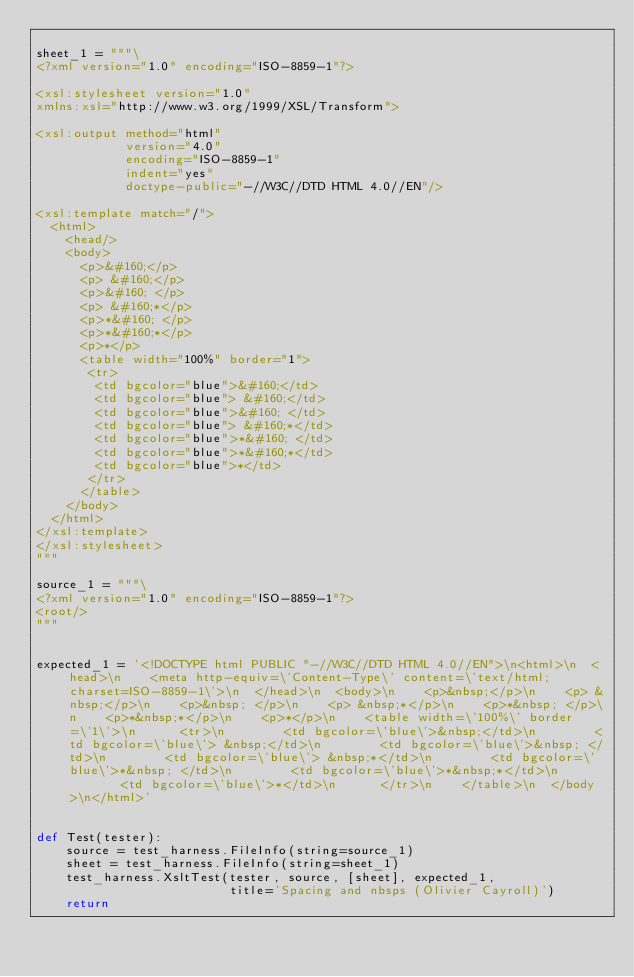Convert code to text. <code><loc_0><loc_0><loc_500><loc_500><_Python_>
sheet_1 = """\
<?xml version="1.0" encoding="ISO-8859-1"?>

<xsl:stylesheet version="1.0"
xmlns:xsl="http://www.w3.org/1999/XSL/Transform">

<xsl:output method="html"
            version="4.0" 
            encoding="ISO-8859-1" 
            indent="yes" 
            doctype-public="-//W3C//DTD HTML 4.0//EN"/>

<xsl:template match="/">
  <html>
    <head/>
    <body>
      <p>&#160;</p>
      <p> &#160;</p>
      <p>&#160; </p>
      <p> &#160;*</p>
      <p>*&#160; </p>
      <p>*&#160;*</p>
      <p>*</p>
      <table width="100%" border="1">
       <tr>
        <td bgcolor="blue">&#160;</td>
        <td bgcolor="blue"> &#160;</td>
        <td bgcolor="blue">&#160; </td>
        <td bgcolor="blue"> &#160;*</td>
        <td bgcolor="blue">*&#160; </td>
        <td bgcolor="blue">*&#160;*</td>
        <td bgcolor="blue">*</td>
       </tr>
      </table>
    </body>
  </html>
</xsl:template>
</xsl:stylesheet>
"""

source_1 = """\
<?xml version="1.0" encoding="ISO-8859-1"?>
<root/>
"""


expected_1 = '<!DOCTYPE html PUBLIC "-//W3C//DTD HTML 4.0//EN">\n<html>\n  <head>\n    <meta http-equiv=\'Content-Type\' content=\'text/html; charset=ISO-8859-1\'>\n  </head>\n  <body>\n    <p>&nbsp;</p>\n    <p> &nbsp;</p>\n    <p>&nbsp; </p>\n    <p> &nbsp;*</p>\n    <p>*&nbsp; </p>\n    <p>*&nbsp;*</p>\n    <p>*</p>\n    <table width=\'100%\' border=\'1\'>\n      <tr>\n        <td bgcolor=\'blue\'>&nbsp;</td>\n        <td bgcolor=\'blue\'> &nbsp;</td>\n        <td bgcolor=\'blue\'>&nbsp; </td>\n        <td bgcolor=\'blue\'> &nbsp;*</td>\n        <td bgcolor=\'blue\'>*&nbsp; </td>\n        <td bgcolor=\'blue\'>*&nbsp;*</td>\n        <td bgcolor=\'blue\'>*</td>\n      </tr>\n    </table>\n  </body>\n</html>'


def Test(tester):
    source = test_harness.FileInfo(string=source_1)
    sheet = test_harness.FileInfo(string=sheet_1)
    test_harness.XsltTest(tester, source, [sheet], expected_1,
                          title='Spacing and nbsps (Olivier Cayroll)')
    return
</code> 